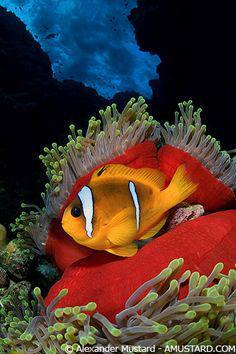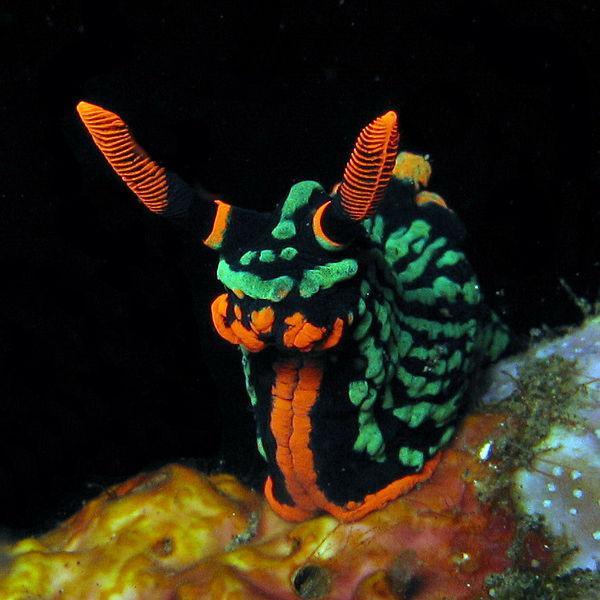The first image is the image on the left, the second image is the image on the right. For the images displayed, is the sentence "There is exactly one clown fish." factually correct? Answer yes or no. Yes. The first image is the image on the left, the second image is the image on the right. Assess this claim about the two images: "Each image shows at least two brightly colored striped fish of the same variety swimming in a scene that contains anemone tendrils.". Correct or not? Answer yes or no. No. 